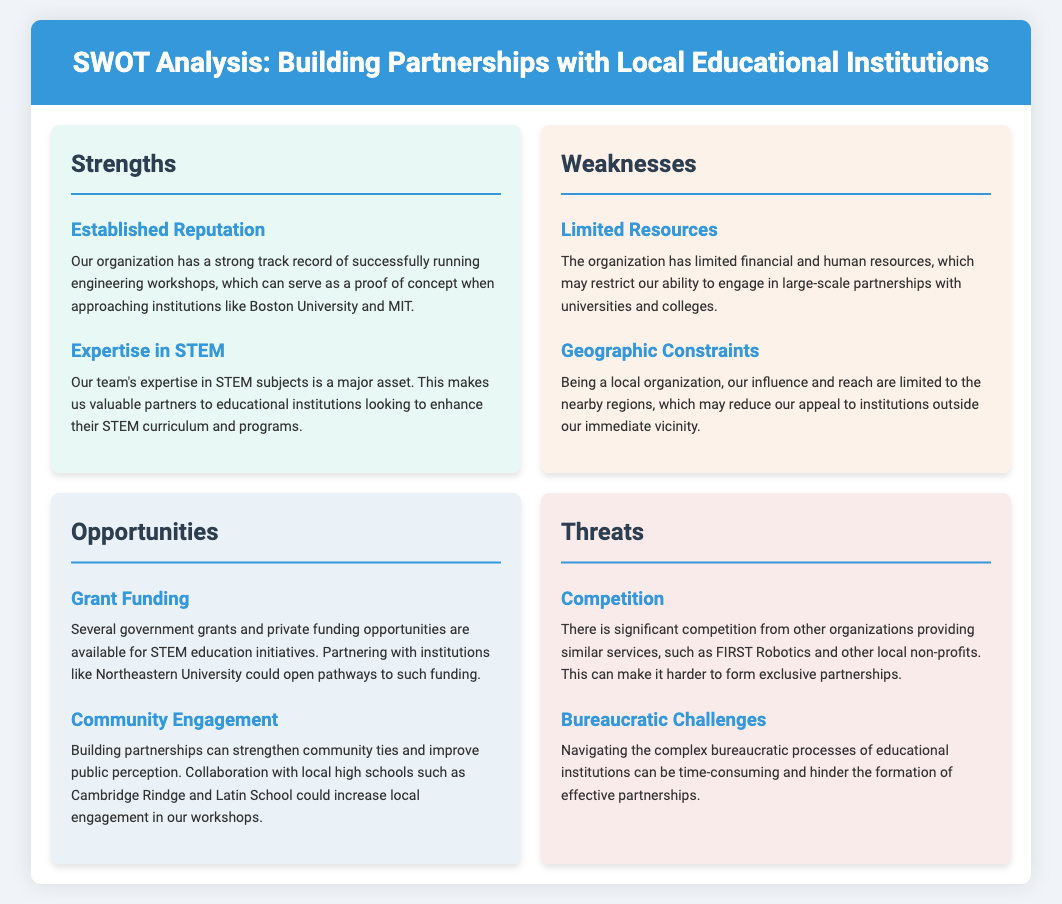What is one strength of the organization? The document lists a strong track record of successfully running engineering workshops as a strength.
Answer: Established Reputation What is a major weakness mentioned? Limited financial and human resources are identified as a significant weakness in the document.
Answer: Limited Resources Which educational institutions are mentioned as potential partners? The document mentions Boston University, MIT, and Northeastern University as potential partners.
Answer: Boston University and MIT What opportunity relates to funding? The document states that several government grants and private funding opportunities are available for STEM education initiatives.
Answer: Grant Funding What is one threat to forming partnerships? One threat identified in the document is the significant competition from other organizations providing similar services.
Answer: Competition How many strengths are listed in the document? The document lists two strengths specifically related to building partnerships.
Answer: Two What collaboration could enhance local engagement? The document suggests collaboration with local high schools to enhance community engagement.
Answer: Cambridge Rindge and Latin School What is a bureaucratic challenge mentioned? The document mentions that navigating complex bureaucratic processes can hinder effective partnerships.
Answer: Bureaucratic Challenges 